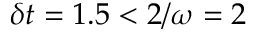<formula> <loc_0><loc_0><loc_500><loc_500>\delta t = 1 . 5 < 2 / \omega = 2</formula> 